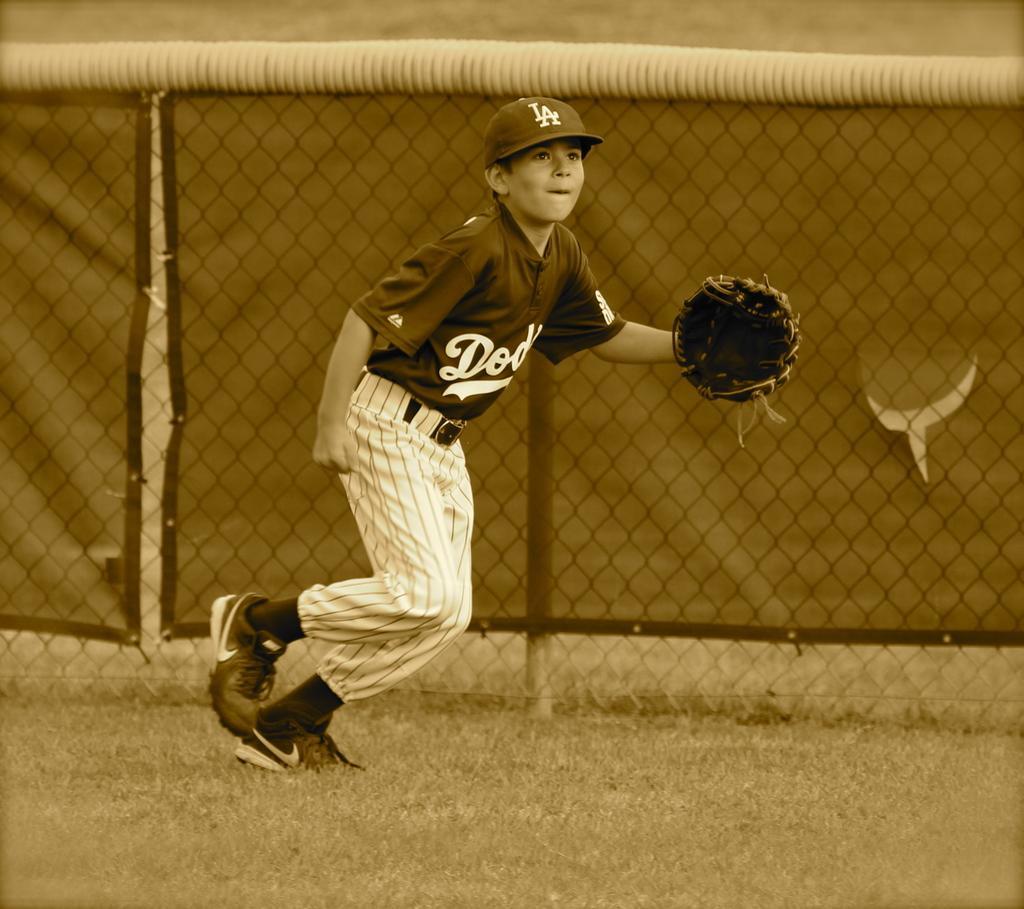In one or two sentences, can you explain what this image depicts? In this image I can see a boy is standing. I can see he is wearing sports wear, a glove and a cap. In the background I can see fencing and on his dress I can see something is written. I can also see this image is little bit in brown colour. 